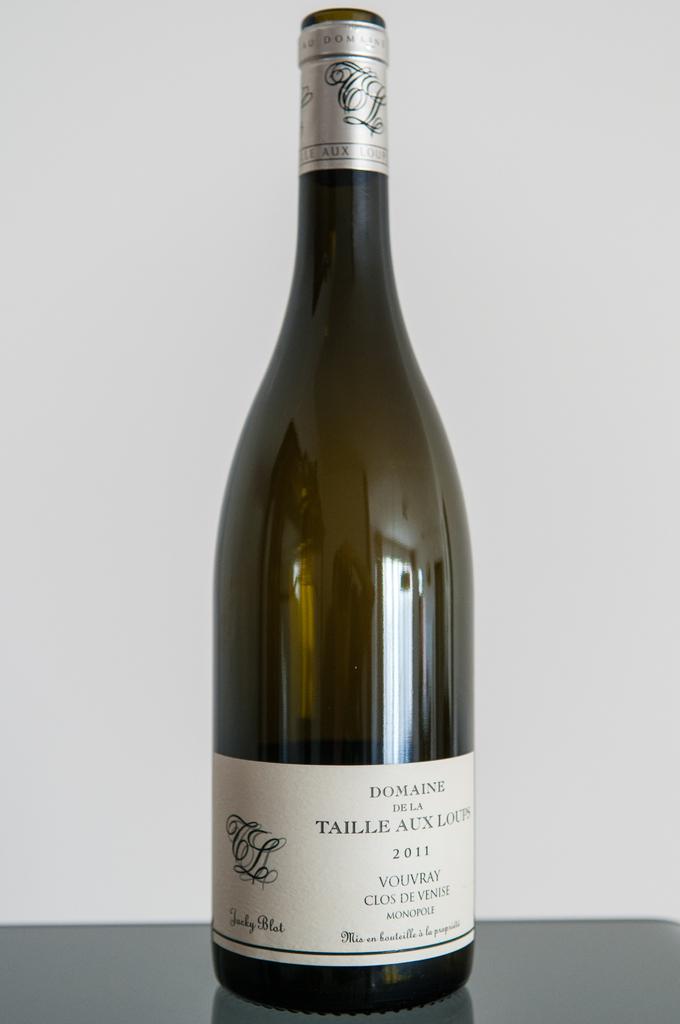What year is the alcoholic beverage?
Provide a succinct answer. 2011. 